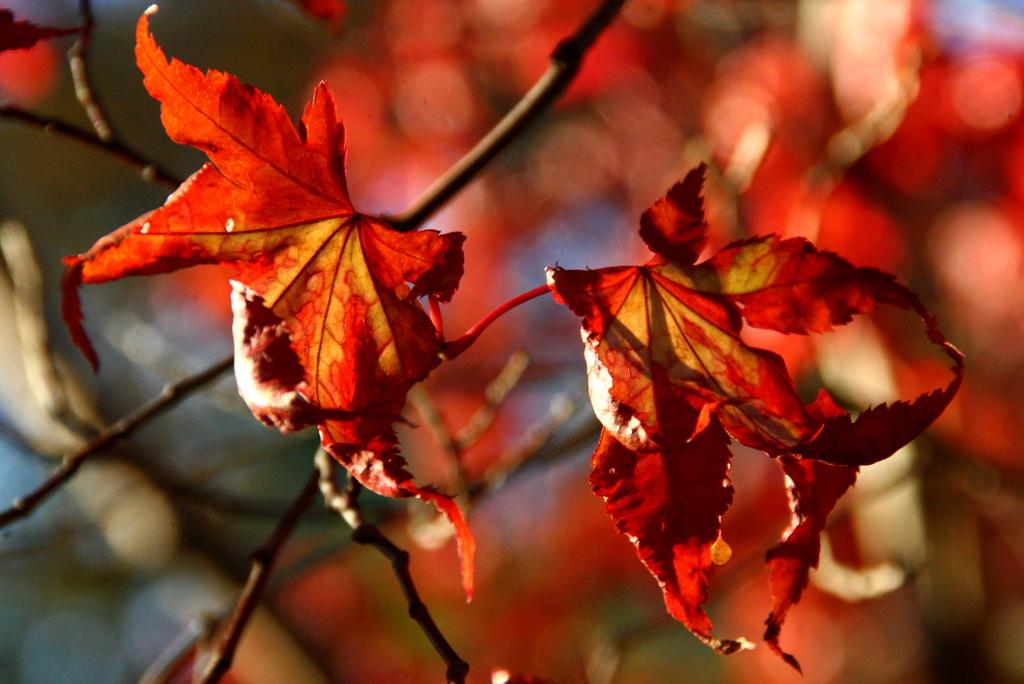What color are the leaves on the tree in the image? The leaves on the tree in the image are red. Can you describe the background of the image? The background of the image is blurred. What type of insurance policy is being discussed by the flock of birds in the image? There are no birds present in the image, and therefore no discussion about insurance policies can be observed. 